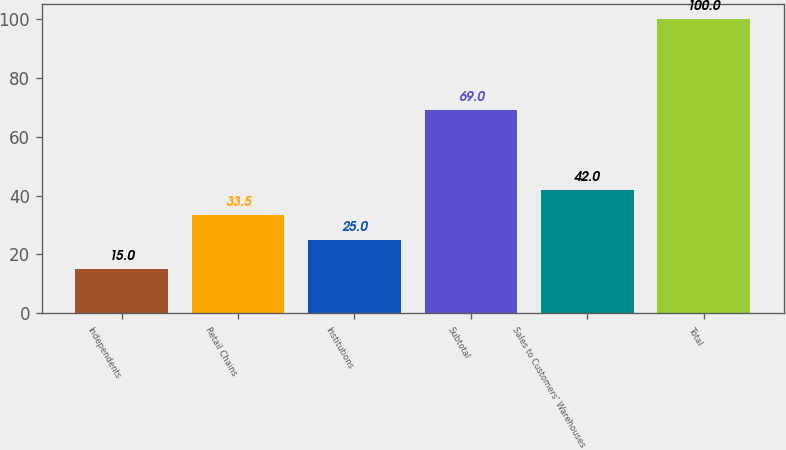<chart> <loc_0><loc_0><loc_500><loc_500><bar_chart><fcel>Independents<fcel>Retail Chains<fcel>Institutions<fcel>Subtotal<fcel>Sales to Customers' Warehouses<fcel>Total<nl><fcel>15<fcel>33.5<fcel>25<fcel>69<fcel>42<fcel>100<nl></chart> 